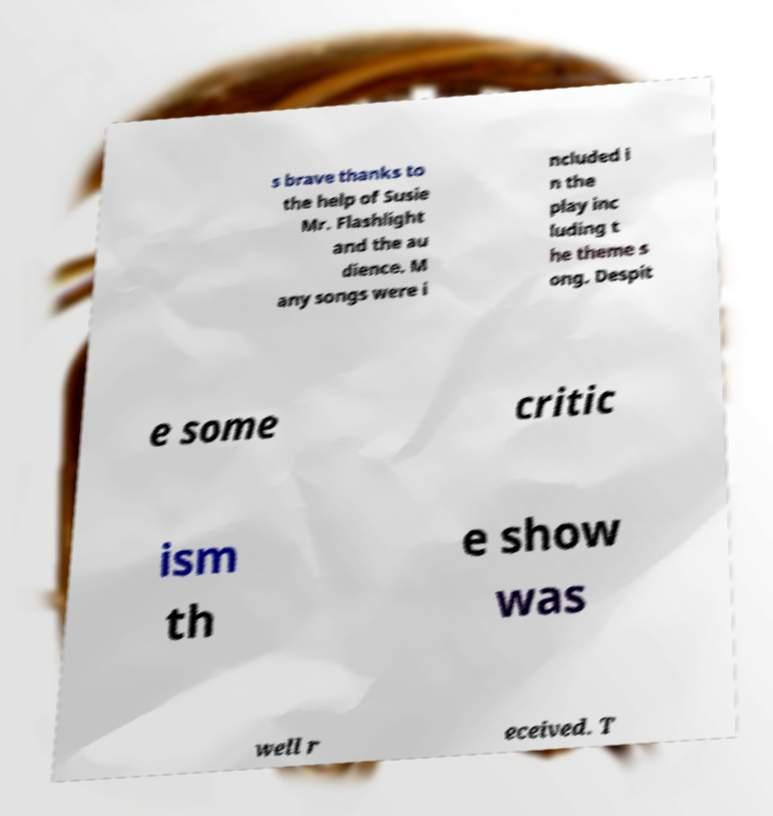Please read and relay the text visible in this image. What does it say? s brave thanks to the help of Susie Mr. Flashlight and the au dience. M any songs were i ncluded i n the play inc luding t he theme s ong. Despit e some critic ism th e show was well r eceived. T 